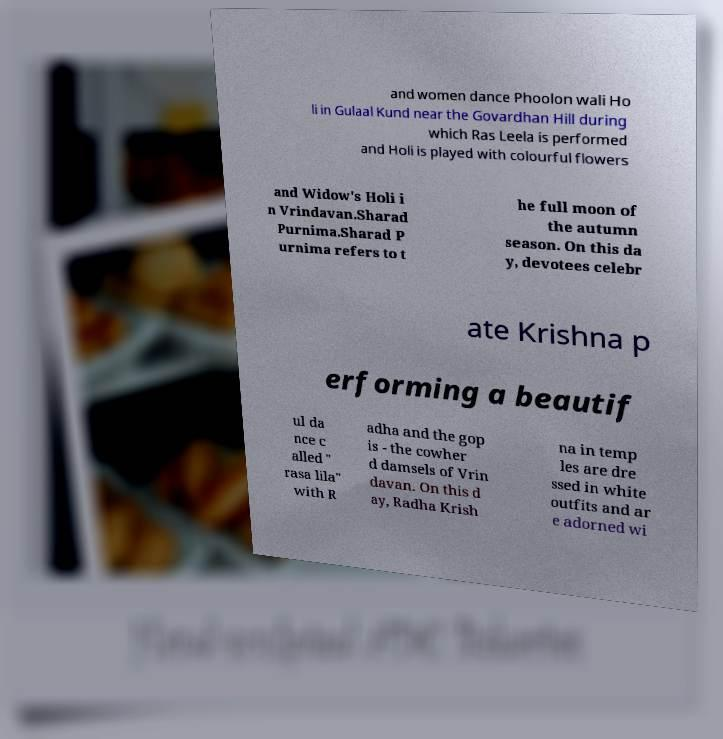There's text embedded in this image that I need extracted. Can you transcribe it verbatim? and women dance Phoolon wali Ho li in Gulaal Kund near the Govardhan Hill during which Ras Leela is performed and Holi is played with colourful flowers and Widow's Holi i n Vrindavan.Sharad Purnima.Sharad P urnima refers to t he full moon of the autumn season. On this da y, devotees celebr ate Krishna p erforming a beautif ul da nce c alled " rasa lila" with R adha and the gop is - the cowher d damsels of Vrin davan. On this d ay, Radha Krish na in temp les are dre ssed in white outfits and ar e adorned wi 